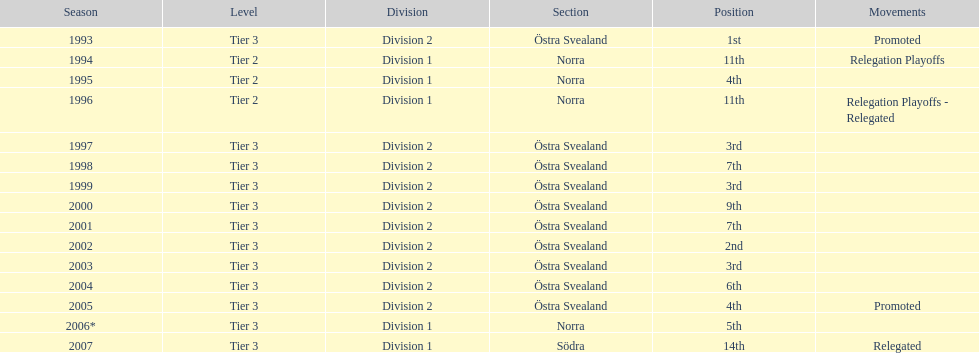What are the number of times norra was listed as the section? 4. 